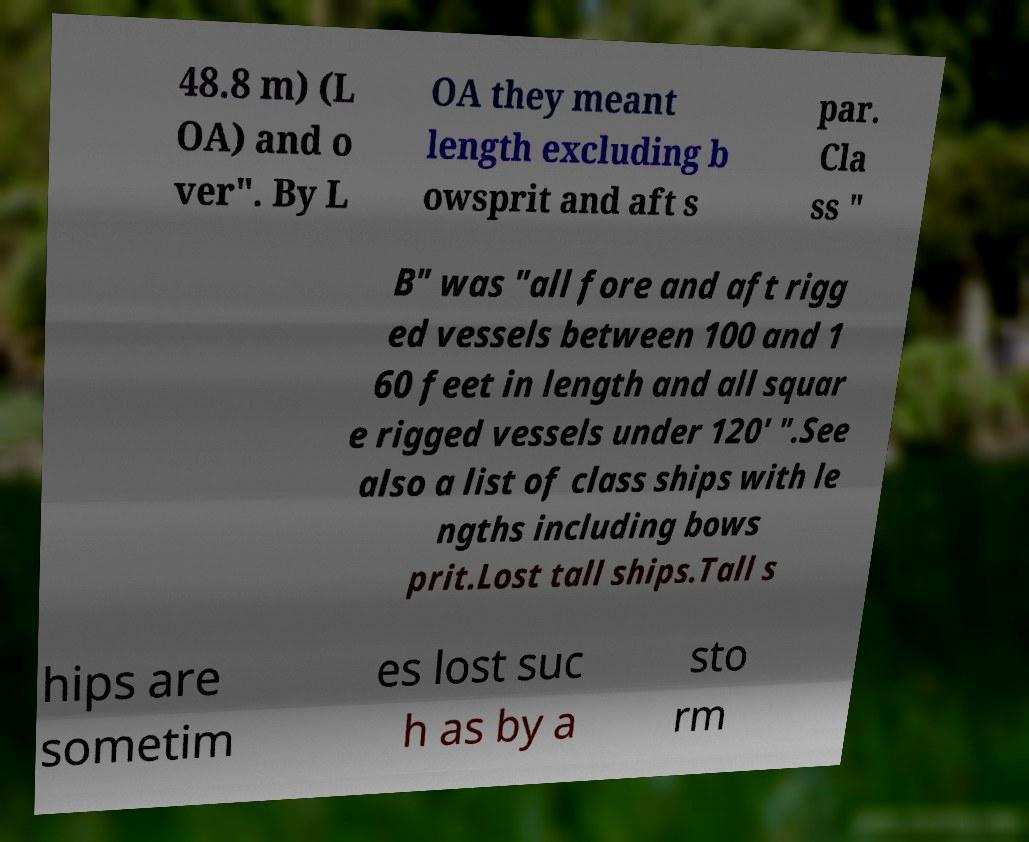Could you extract and type out the text from this image? 48.8 m) (L OA) and o ver". By L OA they meant length excluding b owsprit and aft s par. Cla ss " B" was "all fore and aft rigg ed vessels between 100 and 1 60 feet in length and all squar e rigged vessels under 120′ ".See also a list of class ships with le ngths including bows prit.Lost tall ships.Tall s hips are sometim es lost suc h as by a sto rm 